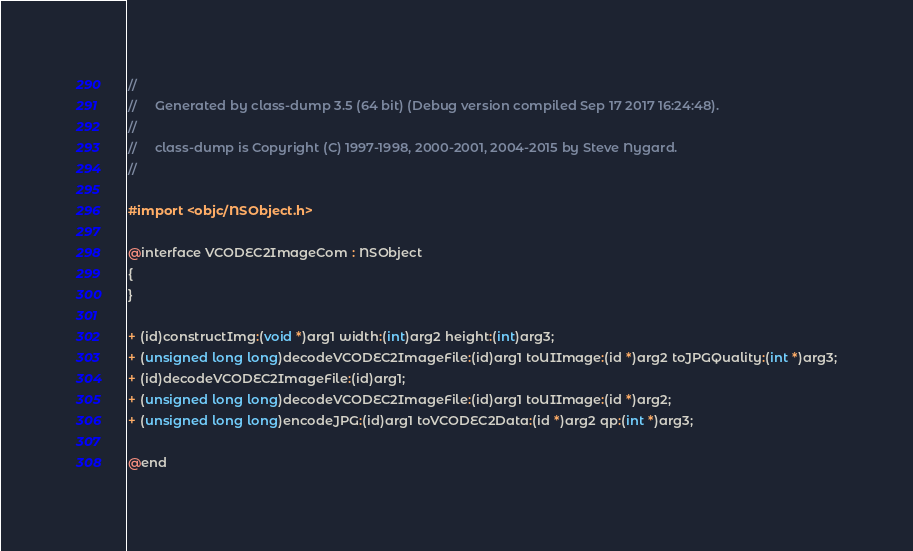<code> <loc_0><loc_0><loc_500><loc_500><_C_>//
//     Generated by class-dump 3.5 (64 bit) (Debug version compiled Sep 17 2017 16:24:48).
//
//     class-dump is Copyright (C) 1997-1998, 2000-2001, 2004-2015 by Steve Nygard.
//

#import <objc/NSObject.h>

@interface VCODEC2ImageCom : NSObject
{
}

+ (id)constructImg:(void *)arg1 width:(int)arg2 height:(int)arg3;
+ (unsigned long long)decodeVCODEC2ImageFile:(id)arg1 toUIImage:(id *)arg2 toJPGQuality:(int *)arg3;
+ (id)decodeVCODEC2ImageFile:(id)arg1;
+ (unsigned long long)decodeVCODEC2ImageFile:(id)arg1 toUIImage:(id *)arg2;
+ (unsigned long long)encodeJPG:(id)arg1 toVCODEC2Data:(id *)arg2 qp:(int *)arg3;

@end

</code> 